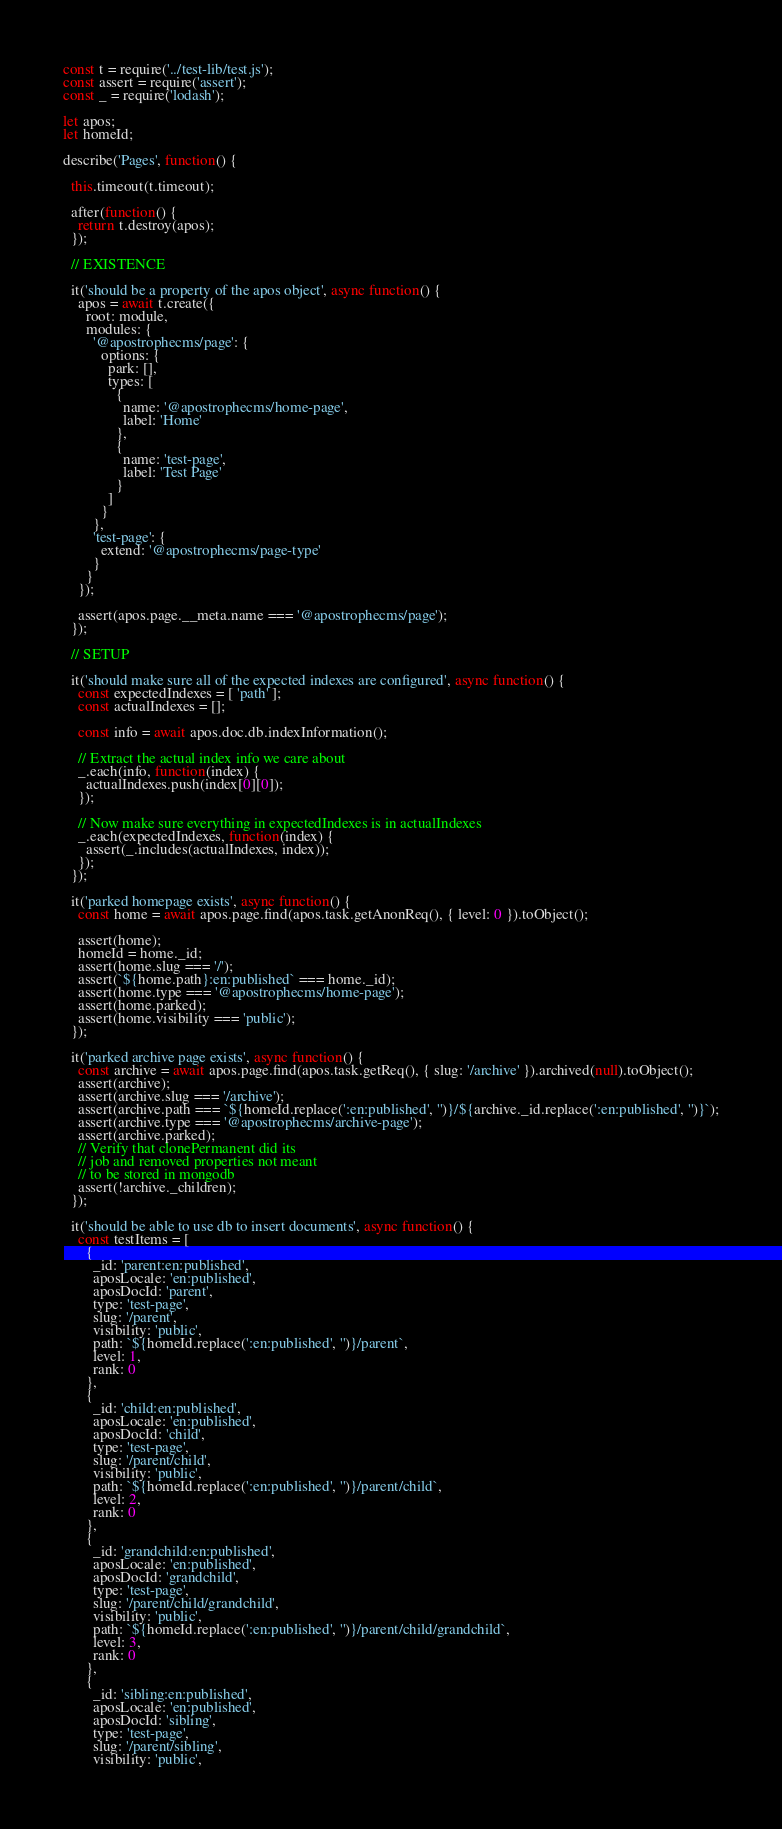<code> <loc_0><loc_0><loc_500><loc_500><_JavaScript_>const t = require('../test-lib/test.js');
const assert = require('assert');
const _ = require('lodash');

let apos;
let homeId;

describe('Pages', function() {

  this.timeout(t.timeout);

  after(function() {
    return t.destroy(apos);
  });

  // EXISTENCE

  it('should be a property of the apos object', async function() {
    apos = await t.create({
      root: module,
      modules: {
        '@apostrophecms/page': {
          options: {
            park: [],
            types: [
              {
                name: '@apostrophecms/home-page',
                label: 'Home'
              },
              {
                name: 'test-page',
                label: 'Test Page'
              }
            ]
          }
        },
        'test-page': {
          extend: '@apostrophecms/page-type'
        }
      }
    });

    assert(apos.page.__meta.name === '@apostrophecms/page');
  });

  // SETUP

  it('should make sure all of the expected indexes are configured', async function() {
    const expectedIndexes = [ 'path' ];
    const actualIndexes = [];

    const info = await apos.doc.db.indexInformation();

    // Extract the actual index info we care about
    _.each(info, function(index) {
      actualIndexes.push(index[0][0]);
    });

    // Now make sure everything in expectedIndexes is in actualIndexes
    _.each(expectedIndexes, function(index) {
      assert(_.includes(actualIndexes, index));
    });
  });

  it('parked homepage exists', async function() {
    const home = await apos.page.find(apos.task.getAnonReq(), { level: 0 }).toObject();

    assert(home);
    homeId = home._id;
    assert(home.slug === '/');
    assert(`${home.path}:en:published` === home._id);
    assert(home.type === '@apostrophecms/home-page');
    assert(home.parked);
    assert(home.visibility === 'public');
  });

  it('parked archive page exists', async function() {
    const archive = await apos.page.find(apos.task.getReq(), { slug: '/archive' }).archived(null).toObject();
    assert(archive);
    assert(archive.slug === '/archive');
    assert(archive.path === `${homeId.replace(':en:published', '')}/${archive._id.replace(':en:published', '')}`);
    assert(archive.type === '@apostrophecms/archive-page');
    assert(archive.parked);
    // Verify that clonePermanent did its
    // job and removed properties not meant
    // to be stored in mongodb
    assert(!archive._children);
  });

  it('should be able to use db to insert documents', async function() {
    const testItems = [
      {
        _id: 'parent:en:published',
        aposLocale: 'en:published',
        aposDocId: 'parent',
        type: 'test-page',
        slug: '/parent',
        visibility: 'public',
        path: `${homeId.replace(':en:published', '')}/parent`,
        level: 1,
        rank: 0
      },
      {
        _id: 'child:en:published',
        aposLocale: 'en:published',
        aposDocId: 'child',
        type: 'test-page',
        slug: '/parent/child',
        visibility: 'public',
        path: `${homeId.replace(':en:published', '')}/parent/child`,
        level: 2,
        rank: 0
      },
      {
        _id: 'grandchild:en:published',
        aposLocale: 'en:published',
        aposDocId: 'grandchild',
        type: 'test-page',
        slug: '/parent/child/grandchild',
        visibility: 'public',
        path: `${homeId.replace(':en:published', '')}/parent/child/grandchild`,
        level: 3,
        rank: 0
      },
      {
        _id: 'sibling:en:published',
        aposLocale: 'en:published',
        aposDocId: 'sibling',
        type: 'test-page',
        slug: '/parent/sibling',
        visibility: 'public',</code> 